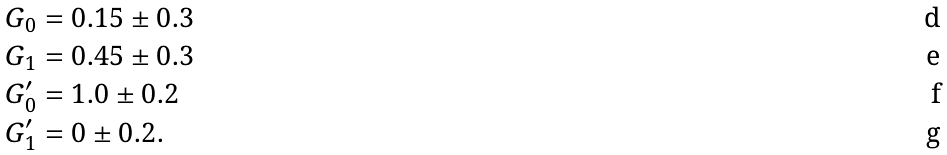<formula> <loc_0><loc_0><loc_500><loc_500>G _ { 0 } & = 0 . 1 5 \pm 0 . 3 \\ G _ { 1 } & = 0 . 4 5 \pm 0 . 3 \\ G _ { 0 } ^ { \prime } & = 1 . 0 \pm 0 . 2 \\ G _ { 1 } ^ { \prime } & = 0 \pm 0 . 2 .</formula> 